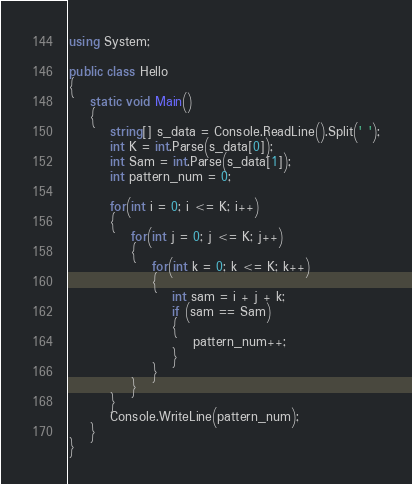Convert code to text. <code><loc_0><loc_0><loc_500><loc_500><_C#_>using System;

public class Hello
{
    static void Main()
    {
        string[] s_data = Console.ReadLine().Split(' ');
        int K = int.Parse(s_data[0]);
        int Sam = int.Parse(s_data[1]);
        int pattern_num = 0;

        for(int i = 0; i <= K; i++)
        {
            for(int j = 0; j <= K; j++)
            {
                for(int k = 0; k <= K; k++)
                {
                    int sam = i + j + k;
                    if (sam == Sam)
                    {
                        pattern_num++;
                    }
                }
            }
        }
        Console.WriteLine(pattern_num);
    }
}</code> 